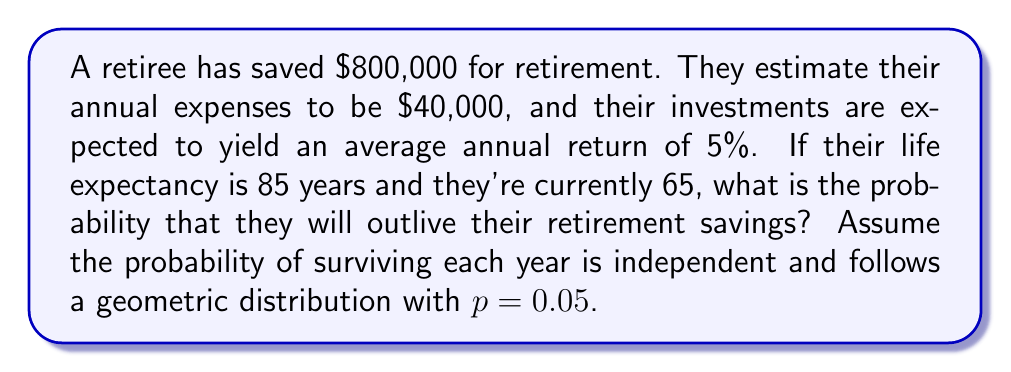Provide a solution to this math problem. Let's approach this step-by-step:

1) First, we need to calculate how long the retirement savings will last:
   Let $S_n$ be the savings after $n$ years:
   $$S_n = S_{n-1} \cdot 1.05 - 40000$$
   $$S_0 = 800000$$

   Using a calculator or spreadsheet, we find that the savings will last for 31 years.

2) Now, we need to calculate the probability of living beyond 31 years after retirement:
   The retiree is 65 now, so we're looking at the probability of living past 96 years old.

3) The probability of surviving each year is modeled as a geometric distribution with $p = 0.05$. The probability of surviving for at least $k$ years is:
   $$P(X \geq k) = (1-p)^{k-1} = 0.95^{k-1}$$

4) In this case, $k = 31$ (we want to survive at least 31 years):
   $$P(X \geq 31) = 0.95^{30} \approx 0.2146$$

5) Therefore, the probability of outliving the retirement savings is approximately 0.2146 or 21.46%.
Answer: $0.2146$ or $21.46\%$ 